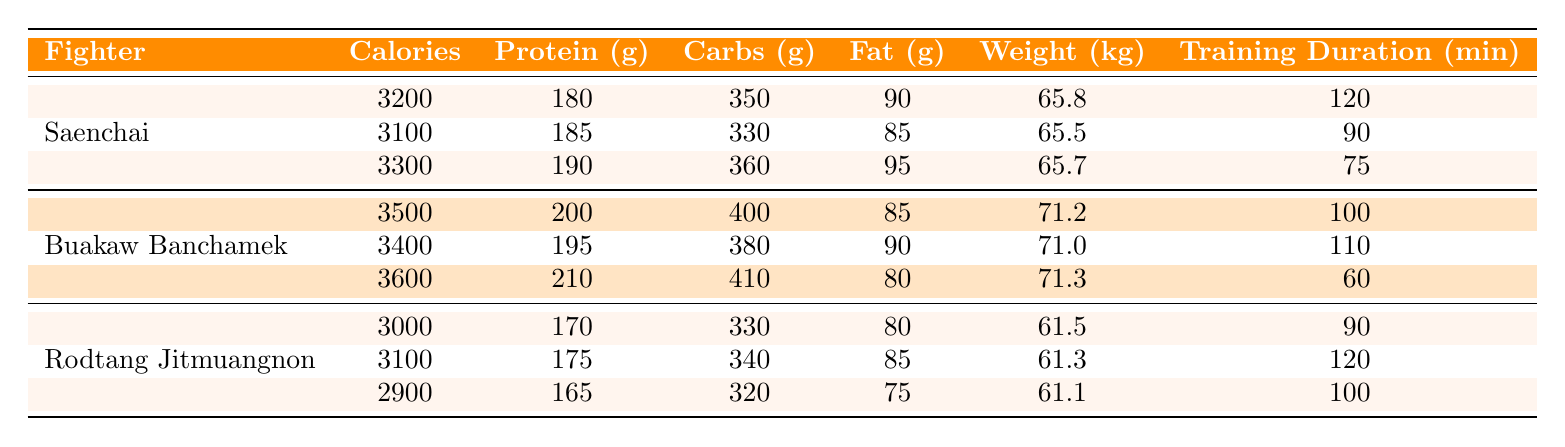What is the total caloric intake for Saenchai over the three days? To find the total caloric intake, we add the calories from each day: 3200 + 3100 + 3300 = 9600.
Answer: 9600 What was Rodtang's weight increase from May 1 to May 3? Rodtang's weight on May 1 was 61.5 kg and on May 3 it was 61.1 kg. The increase is calculated as 61.1 - 61.5 = -0.4 kg (indicating a decrease).
Answer: -0.4 kg On which day did Buakaw Banchamek have the highest protein intake? By checking the protein intake values, on May 3, Buakaw consumed 210 grams, which is higher than the other two days (200 g and 195 g).
Answer: May 3 What is the average training duration for all fighters across the three days? The total training duration for all fighters is (120 + 90 + 75 + 100 + 110 + 60 + 90 + 120 + 100) = 975 minutes for 9 entries. The average is therefore 975 / 9 ≈ 108.33 minutes.
Answer: 108.33 minutes Did Saenchai's daily fat intake fluctuate above 90 grams? Saenchai's fat intake was 90 g on May 1, 85 g on May 2, and 95 g on May 3. It reached 95 g on May 3, indicating fluctuation above 90 grams.
Answer: Yes Which fighter had the lowest caloric intake on May 2? On May 2, Saenchai had 3100 calories, Buakaw had 3400 calories, and Rodtang had 3100 calories. Since both Saenchai and Rodtang had the same lower value of 3100, we can conclude that they tied for the lowest intake.
Answer: Saenchai and Rodtang What is the difference in carbs intake between the fighters on May 1? On May 1, Saenchai had 350 g, Buakaw had 400 g, and Rodtang had 330 g. The differences are calculated as follows: Buakaw (400 g) - Saenchai (350 g) = 50 g, and Saenchai (350 g) - Rodtang (330 g) = 20 g. The maximum difference is 50 g.
Answer: 50 g What was the total protein intake for all fighters on May 3? On May 3, Saenchai had 190 g, Buakaw had 210 g, and Rodtang had 165 g. Adding these gives a total of 190 + 210 + 165 = 565 grams.
Answer: 565 grams 